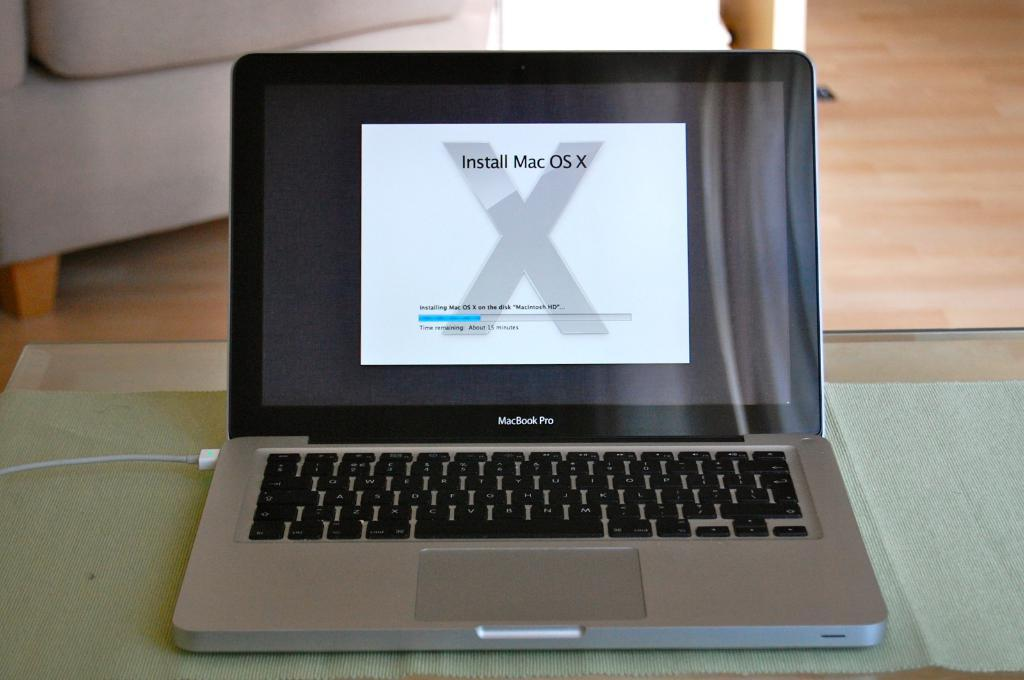<image>
Create a compact narrative representing the image presented. an open macbook pro on a screen that says 'install mac os x' 